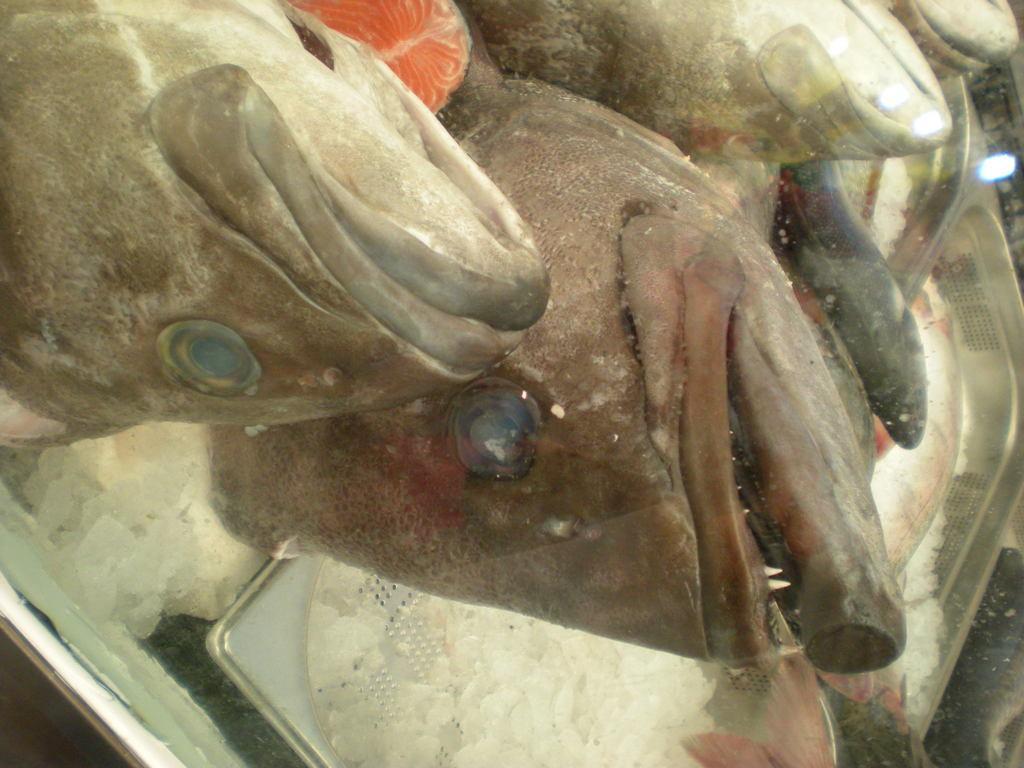In one or two sentences, can you explain what this image depicts? This image is taken indoors. At the bottom of the image there are a few trees with ice cubes in them. In the middle of the image there are a few fishes and a few fish slices. 